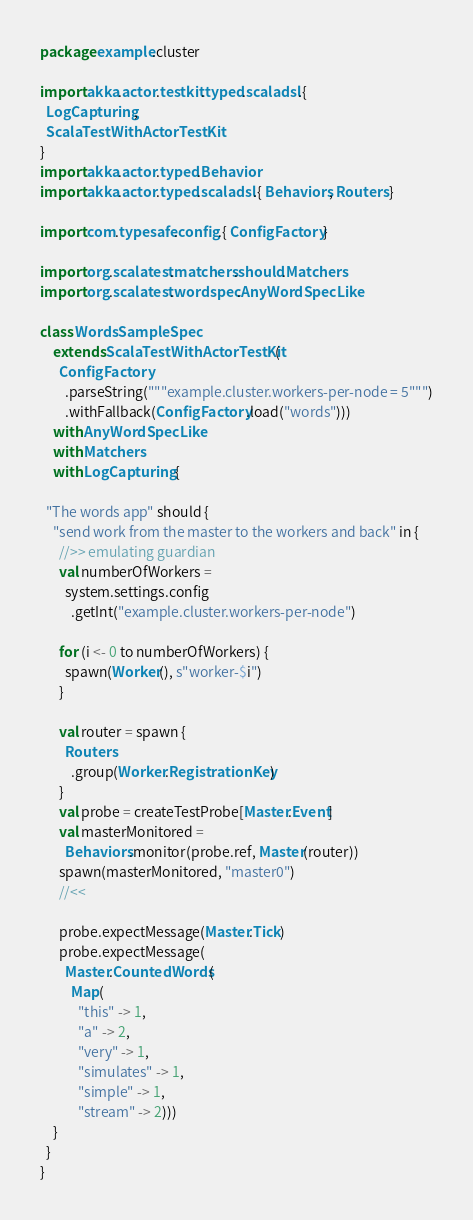Convert code to text. <code><loc_0><loc_0><loc_500><loc_500><_Scala_>package example.cluster

import akka.actor.testkit.typed.scaladsl.{
  LogCapturing,
  ScalaTestWithActorTestKit
}
import akka.actor.typed.Behavior
import akka.actor.typed.scaladsl.{ Behaviors, Routers }

import com.typesafe.config.{ ConfigFactory }

import org.scalatest.matchers.should.Matchers
import org.scalatest.wordspec.AnyWordSpecLike

class WordsSampleSpec
    extends ScalaTestWithActorTestKit(
      ConfigFactory
        .parseString("""example.cluster.workers-per-node = 5""")
        .withFallback(ConfigFactory.load("words")))
    with AnyWordSpecLike
    with Matchers
    with LogCapturing {

  "The words app" should {
    "send work from the master to the workers and back" in {
      //>> emulating guardian
      val numberOfWorkers =
        system.settings.config
          .getInt("example.cluster.workers-per-node")

      for (i <- 0 to numberOfWorkers) {
        spawn(Worker(), s"worker-$i")
      }

      val router = spawn {
        Routers
          .group(Worker.RegistrationKey)
      }
      val probe = createTestProbe[Master.Event]
      val masterMonitored =
        Behaviors.monitor(probe.ref, Master(router))
      spawn(masterMonitored, "master0")
      //<<

      probe.expectMessage(Master.Tick)
      probe.expectMessage(
        Master.CountedWords(
          Map(
            "this" -> 1,
            "a" -> 2,
            "very" -> 1,
            "simulates" -> 1,
            "simple" -> 1,
            "stream" -> 2)))
    }
  }
}
</code> 